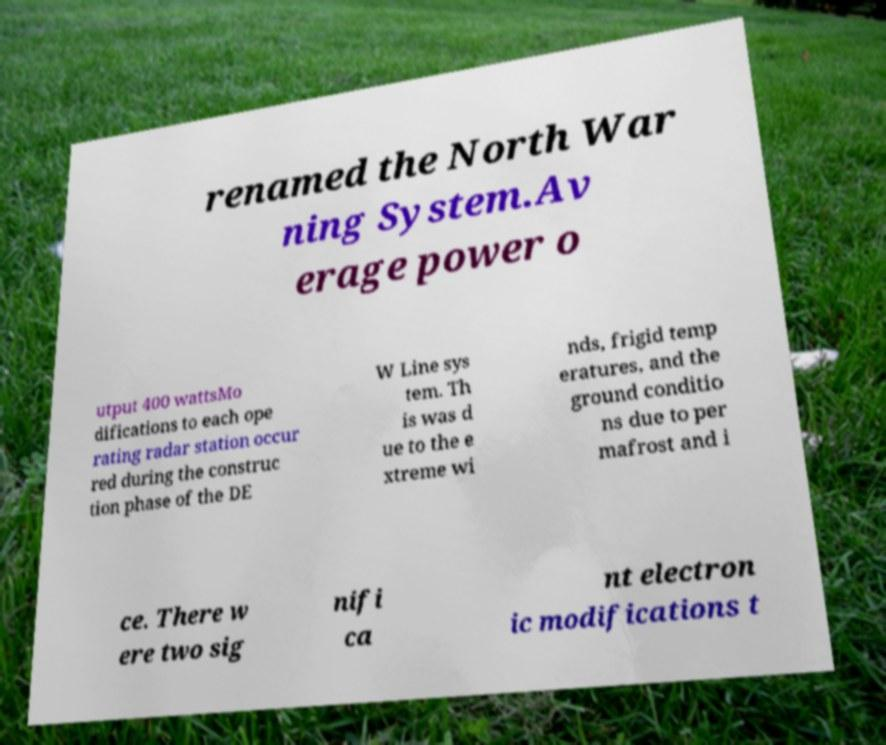I need the written content from this picture converted into text. Can you do that? renamed the North War ning System.Av erage power o utput 400 wattsMo difications to each ope rating radar station occur red during the construc tion phase of the DE W Line sys tem. Th is was d ue to the e xtreme wi nds, frigid temp eratures, and the ground conditio ns due to per mafrost and i ce. There w ere two sig nifi ca nt electron ic modifications t 